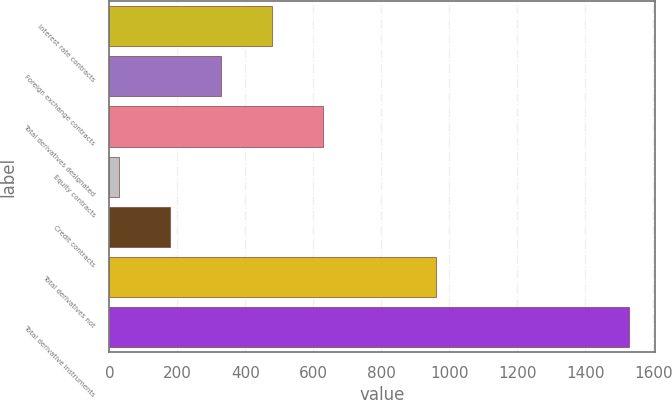Convert chart. <chart><loc_0><loc_0><loc_500><loc_500><bar_chart><fcel>Interest rate contracts<fcel>Foreign exchange contracts<fcel>Total derivatives designated<fcel>Equity contracts<fcel>Credit contracts<fcel>Total derivatives not<fcel>Total derivative instruments<nl><fcel>477.79<fcel>327.76<fcel>627.82<fcel>27.7<fcel>177.73<fcel>960.3<fcel>1528<nl></chart> 